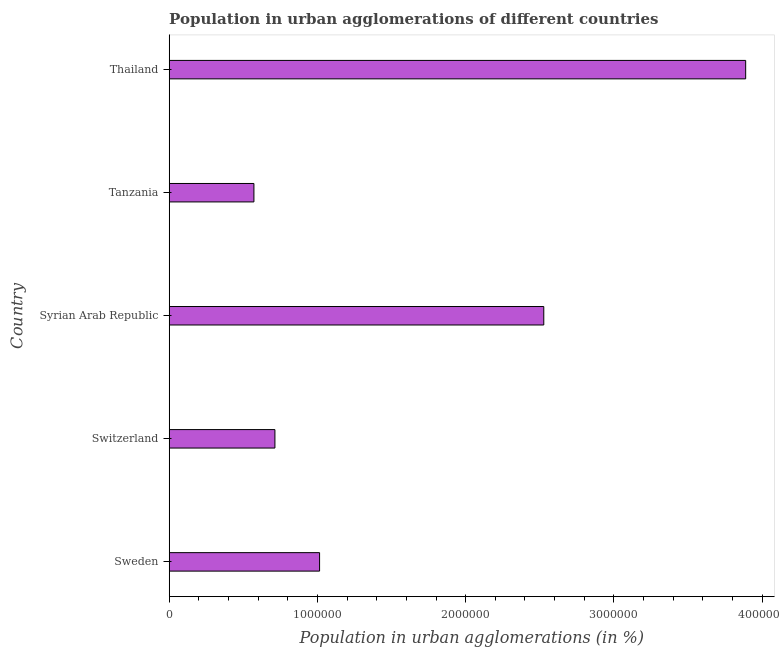Does the graph contain any zero values?
Make the answer very short. No. Does the graph contain grids?
Provide a short and direct response. No. What is the title of the graph?
Your answer should be compact. Population in urban agglomerations of different countries. What is the label or title of the X-axis?
Keep it short and to the point. Population in urban agglomerations (in %). What is the label or title of the Y-axis?
Your answer should be compact. Country. What is the population in urban agglomerations in Switzerland?
Your response must be concise. 7.13e+05. Across all countries, what is the maximum population in urban agglomerations?
Provide a succinct answer. 3.89e+06. Across all countries, what is the minimum population in urban agglomerations?
Your response must be concise. 5.72e+05. In which country was the population in urban agglomerations maximum?
Provide a succinct answer. Thailand. In which country was the population in urban agglomerations minimum?
Keep it short and to the point. Tanzania. What is the sum of the population in urban agglomerations?
Make the answer very short. 8.72e+06. What is the difference between the population in urban agglomerations in Switzerland and Tanzania?
Provide a short and direct response. 1.42e+05. What is the average population in urban agglomerations per country?
Make the answer very short. 1.74e+06. What is the median population in urban agglomerations?
Make the answer very short. 1.01e+06. What is the ratio of the population in urban agglomerations in Switzerland to that in Tanzania?
Ensure brevity in your answer.  1.25. What is the difference between the highest and the second highest population in urban agglomerations?
Your answer should be very brief. 1.36e+06. Is the sum of the population in urban agglomerations in Tanzania and Thailand greater than the maximum population in urban agglomerations across all countries?
Make the answer very short. Yes. What is the difference between the highest and the lowest population in urban agglomerations?
Provide a short and direct response. 3.32e+06. In how many countries, is the population in urban agglomerations greater than the average population in urban agglomerations taken over all countries?
Ensure brevity in your answer.  2. Are the values on the major ticks of X-axis written in scientific E-notation?
Offer a very short reply. No. What is the Population in urban agglomerations (in %) of Sweden?
Your answer should be very brief. 1.01e+06. What is the Population in urban agglomerations (in %) of Switzerland?
Keep it short and to the point. 7.13e+05. What is the Population in urban agglomerations (in %) of Syrian Arab Republic?
Provide a succinct answer. 2.53e+06. What is the Population in urban agglomerations (in %) of Tanzania?
Give a very brief answer. 5.72e+05. What is the Population in urban agglomerations (in %) of Thailand?
Your response must be concise. 3.89e+06. What is the difference between the Population in urban agglomerations (in %) in Sweden and Switzerland?
Ensure brevity in your answer.  3.01e+05. What is the difference between the Population in urban agglomerations (in %) in Sweden and Syrian Arab Republic?
Keep it short and to the point. -1.51e+06. What is the difference between the Population in urban agglomerations (in %) in Sweden and Tanzania?
Keep it short and to the point. 4.43e+05. What is the difference between the Population in urban agglomerations (in %) in Sweden and Thailand?
Your answer should be very brief. -2.87e+06. What is the difference between the Population in urban agglomerations (in %) in Switzerland and Syrian Arab Republic?
Offer a terse response. -1.81e+06. What is the difference between the Population in urban agglomerations (in %) in Switzerland and Tanzania?
Your answer should be very brief. 1.42e+05. What is the difference between the Population in urban agglomerations (in %) in Switzerland and Thailand?
Make the answer very short. -3.18e+06. What is the difference between the Population in urban agglomerations (in %) in Syrian Arab Republic and Tanzania?
Ensure brevity in your answer.  1.96e+06. What is the difference between the Population in urban agglomerations (in %) in Syrian Arab Republic and Thailand?
Keep it short and to the point. -1.36e+06. What is the difference between the Population in urban agglomerations (in %) in Tanzania and Thailand?
Ensure brevity in your answer.  -3.32e+06. What is the ratio of the Population in urban agglomerations (in %) in Sweden to that in Switzerland?
Provide a succinct answer. 1.42. What is the ratio of the Population in urban agglomerations (in %) in Sweden to that in Syrian Arab Republic?
Provide a succinct answer. 0.4. What is the ratio of the Population in urban agglomerations (in %) in Sweden to that in Tanzania?
Keep it short and to the point. 1.77. What is the ratio of the Population in urban agglomerations (in %) in Sweden to that in Thailand?
Give a very brief answer. 0.26. What is the ratio of the Population in urban agglomerations (in %) in Switzerland to that in Syrian Arab Republic?
Keep it short and to the point. 0.28. What is the ratio of the Population in urban agglomerations (in %) in Switzerland to that in Tanzania?
Offer a very short reply. 1.25. What is the ratio of the Population in urban agglomerations (in %) in Switzerland to that in Thailand?
Your answer should be compact. 0.18. What is the ratio of the Population in urban agglomerations (in %) in Syrian Arab Republic to that in Tanzania?
Keep it short and to the point. 4.42. What is the ratio of the Population in urban agglomerations (in %) in Syrian Arab Republic to that in Thailand?
Your response must be concise. 0.65. What is the ratio of the Population in urban agglomerations (in %) in Tanzania to that in Thailand?
Your answer should be very brief. 0.15. 